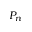<formula> <loc_0><loc_0><loc_500><loc_500>P _ { n }</formula> 